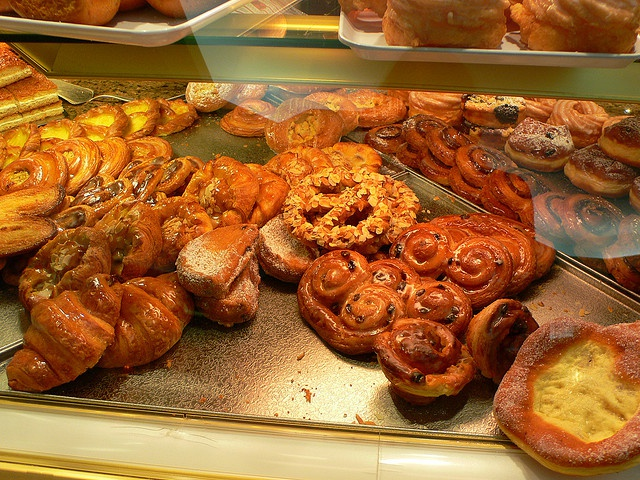Describe the objects in this image and their specific colors. I can see donut in maroon, brown, and red tones, donut in maroon, brown, and orange tones, donut in maroon, red, and brown tones, donut in maroon, red, and brown tones, and cake in maroon, red, orange, and brown tones in this image. 